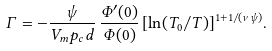<formula> <loc_0><loc_0><loc_500><loc_500>\Gamma = - \frac { \psi } { V _ { m } p _ { c } d } \, \frac { \Phi ^ { \prime } ( 0 ) } { \Phi ( 0 ) } \, [ \ln ( T _ { 0 } / T ) ] ^ { 1 + 1 / ( \nu \psi ) } .</formula> 